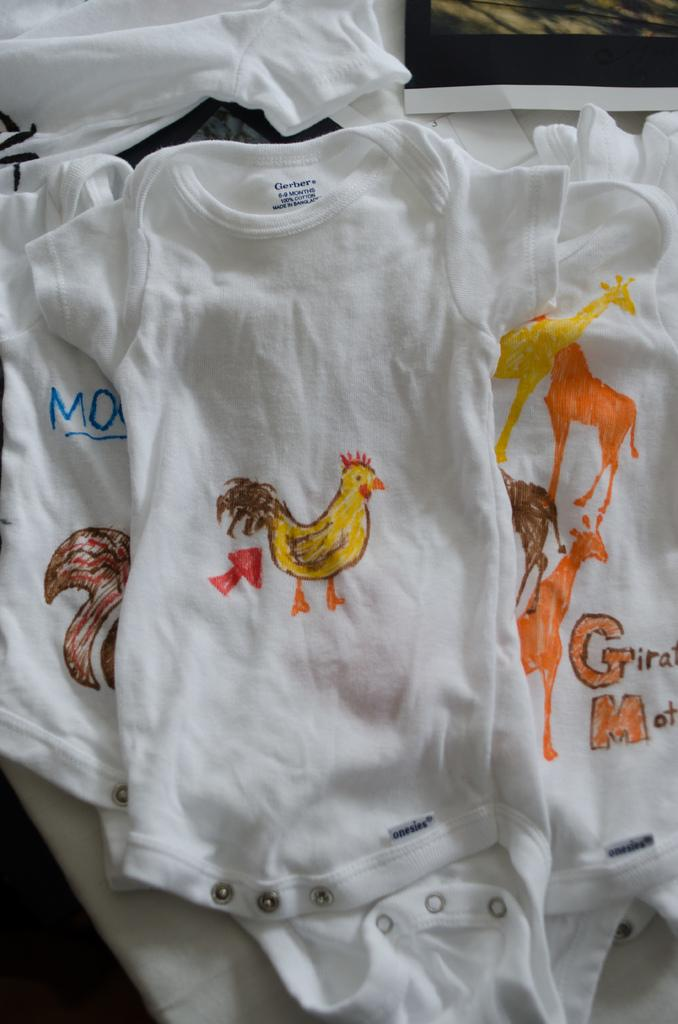What is the main subject in the center of the image? There are t-shirts in the center of the image. What can be seen on the t-shirts? The t-shirts have some objects on them. Can you describe the background of the image? There are objects visible in the background of the image. What type of harmony is being taught in the image? There is no indication of any learning or teaching in the image, nor is there any reference to harmony. 